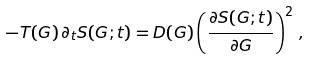Convert formula to latex. <formula><loc_0><loc_0><loc_500><loc_500>- T ( G ) \, \partial _ { t } { S } ( G ; t ) = D ( G ) \left ( \frac { \partial S ( G ; t ) } { \partial G } \right ) ^ { 2 } \, ,</formula> 